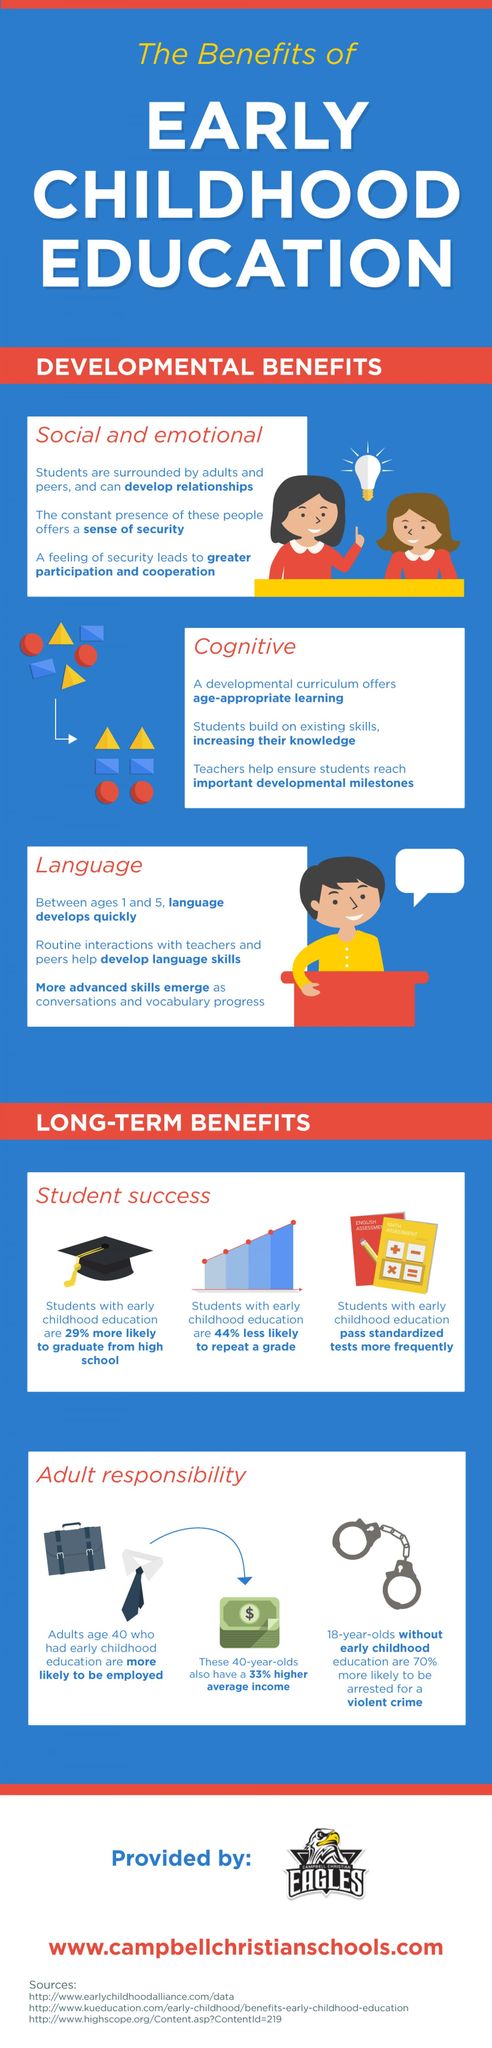Indicate a few pertinent items in this graphic. There are several developmental benefits for early childhood education, including (list 3 specific examples). The long-term benefit of early childhood education is student success and adult responsibility. Early childhood education has been proven to offer numerous developmental benefits, including social and emotional growth, cognitive development, and language acquisition. 